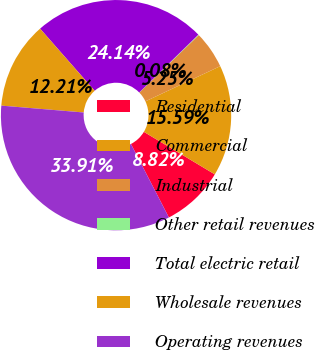Convert chart to OTSL. <chart><loc_0><loc_0><loc_500><loc_500><pie_chart><fcel>Residential<fcel>Commercial<fcel>Industrial<fcel>Other retail revenues<fcel>Total electric retail<fcel>Wholesale revenues<fcel>Operating revenues<nl><fcel>8.82%<fcel>15.59%<fcel>5.25%<fcel>0.08%<fcel>24.14%<fcel>12.21%<fcel>33.91%<nl></chart> 